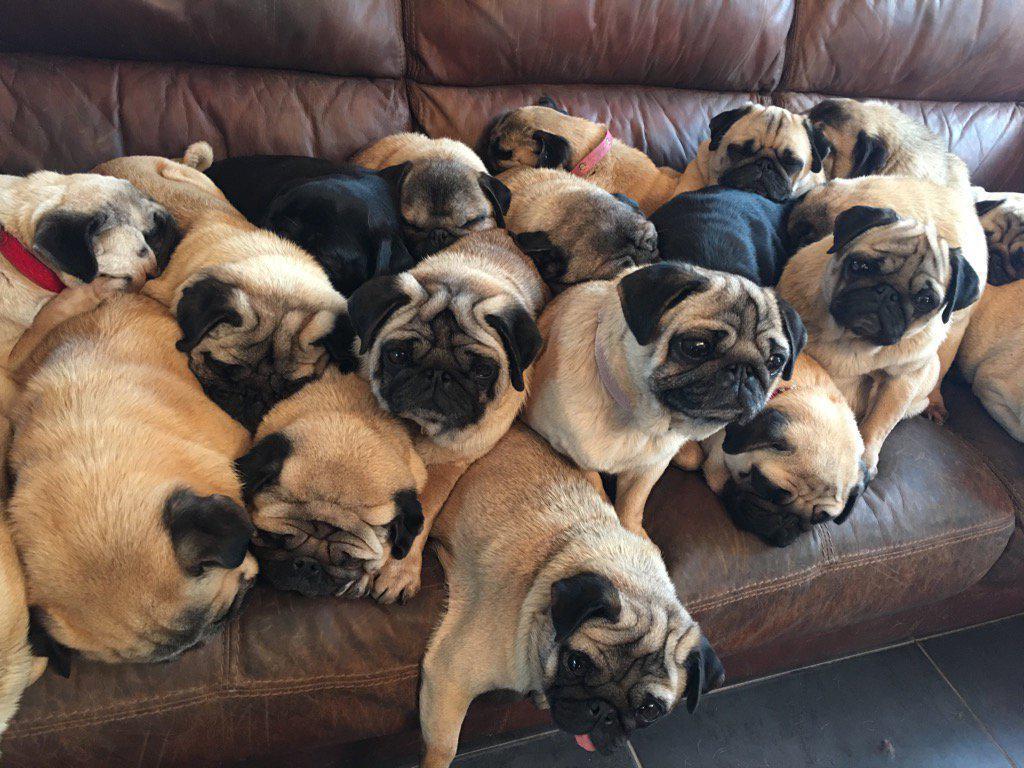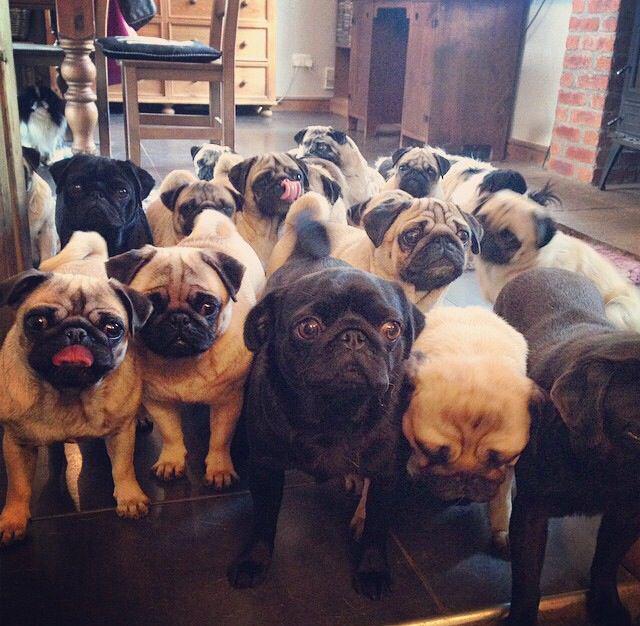The first image is the image on the left, the second image is the image on the right. Analyze the images presented: Is the assertion "At least one image includes black pugs." valid? Answer yes or no. Yes. The first image is the image on the left, the second image is the image on the right. Assess this claim about the two images: "There are no more than four puppies in the image on the right.". Correct or not? Answer yes or no. No. The first image is the image on the left, the second image is the image on the right. Considering the images on both sides, is "There are exactly three dogs in the image on the right." valid? Answer yes or no. No. 